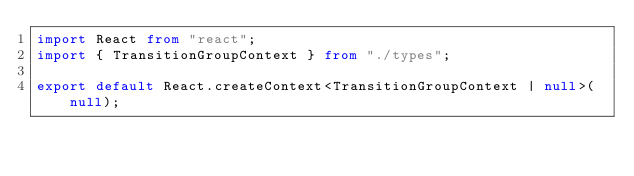Convert code to text. <code><loc_0><loc_0><loc_500><loc_500><_TypeScript_>import React from "react";
import { TransitionGroupContext } from "./types";

export default React.createContext<TransitionGroupContext | null>(null);
</code> 